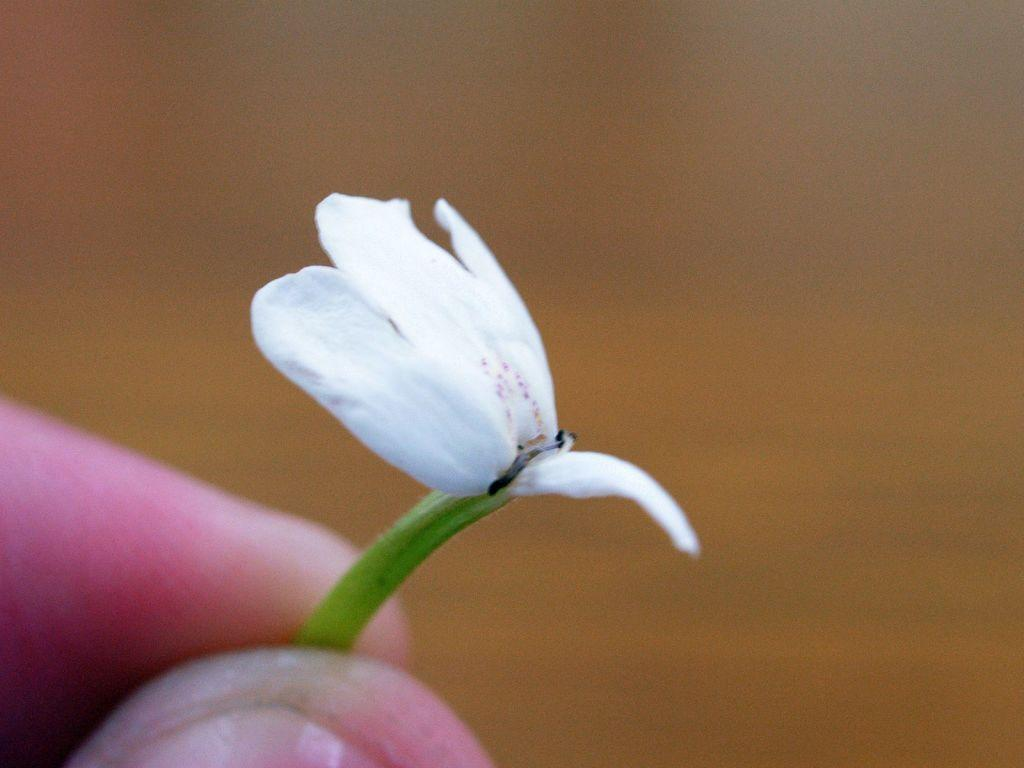What is the person holding in the image? There is a person's hand holding a flower in the image. Can you describe the color of the flower? The flower is white. What can be observed about the background of the image? The background of the image is blurred. What type of sponge is being used to clean the arm in the image? There is no sponge or arm visible in the image; it only shows a person's hand holding a white flower with a blurred background. 